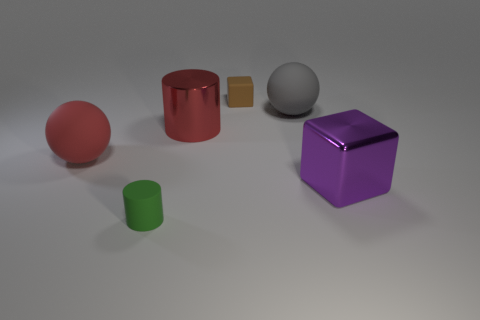Are there fewer shiny objects behind the red rubber sphere than big spheres that are in front of the green matte cylinder?
Offer a very short reply. No. There is a tiny rubber object that is in front of the large rubber ball that is left of the small cube; what shape is it?
Keep it short and to the point. Cylinder. What number of other things are the same material as the big purple thing?
Your answer should be compact. 1. Is there anything else that has the same size as the brown rubber thing?
Ensure brevity in your answer.  Yes. Are there more small matte things than tiny green cylinders?
Offer a terse response. Yes. What size is the metallic object in front of the large red thing to the right of the tiny rubber thing that is in front of the purple cube?
Keep it short and to the point. Large. There is a red cylinder; does it have the same size as the object left of the green matte thing?
Your answer should be compact. Yes. Is the number of rubber spheres to the right of the big gray rubber object less than the number of gray matte balls?
Ensure brevity in your answer.  Yes. How many rubber spheres have the same color as the tiny cylinder?
Give a very brief answer. 0. Is the number of purple metallic cubes less than the number of big purple rubber objects?
Provide a succinct answer. No. 